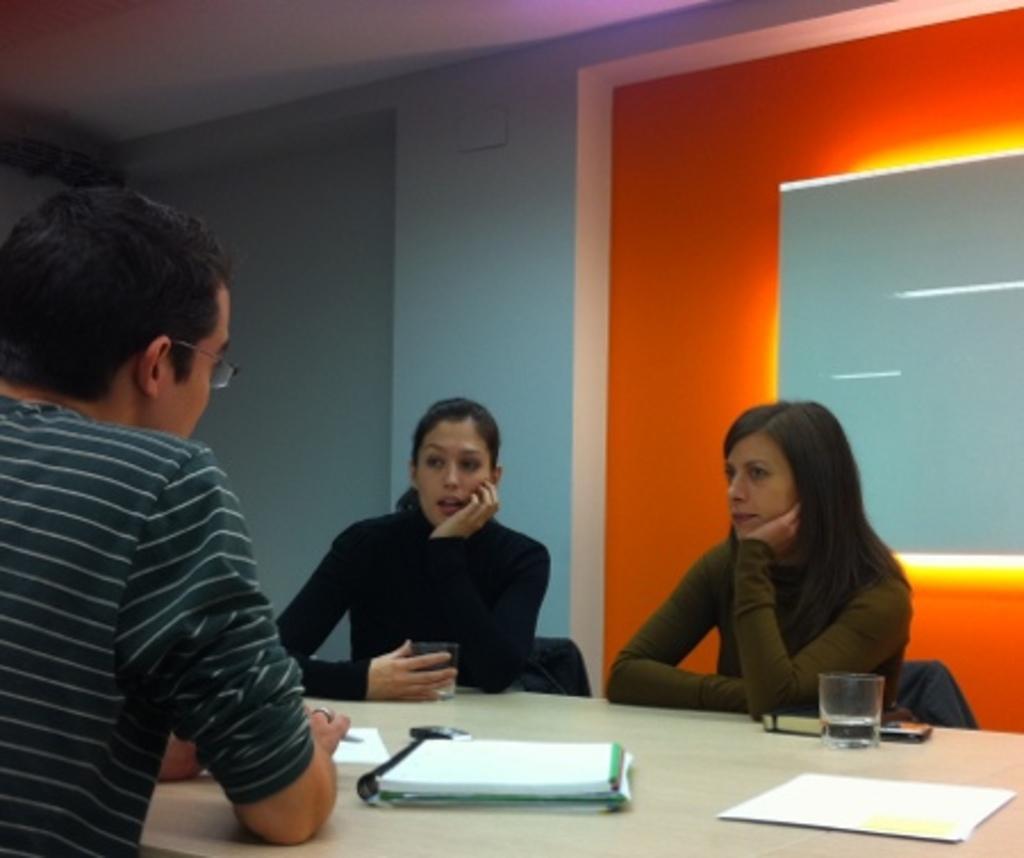How would you summarize this image in a sentence or two? In this picture there is a man sitting here and there two women sitting at the opposite to him, one of them is holding a glass kept on a table, there's a table in front of them with some books, papers, water glass and and many objects and in the backdrop of this wall 